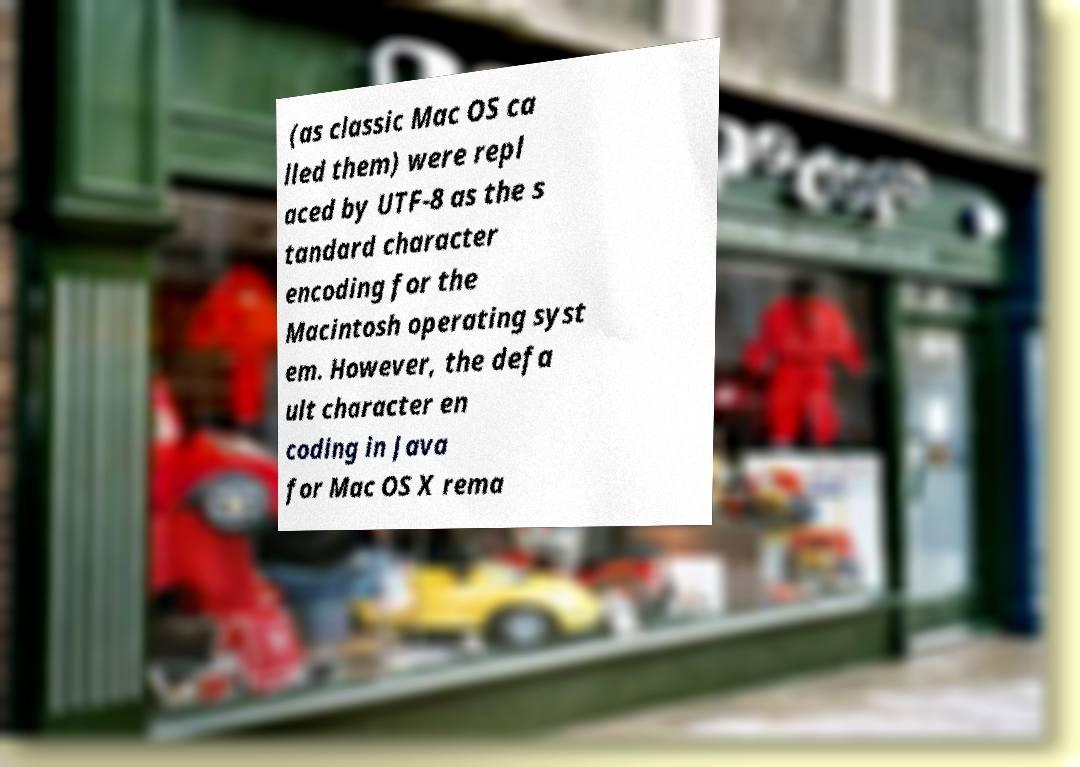Please read and relay the text visible in this image. What does it say? (as classic Mac OS ca lled them) were repl aced by UTF-8 as the s tandard character encoding for the Macintosh operating syst em. However, the defa ult character en coding in Java for Mac OS X rema 